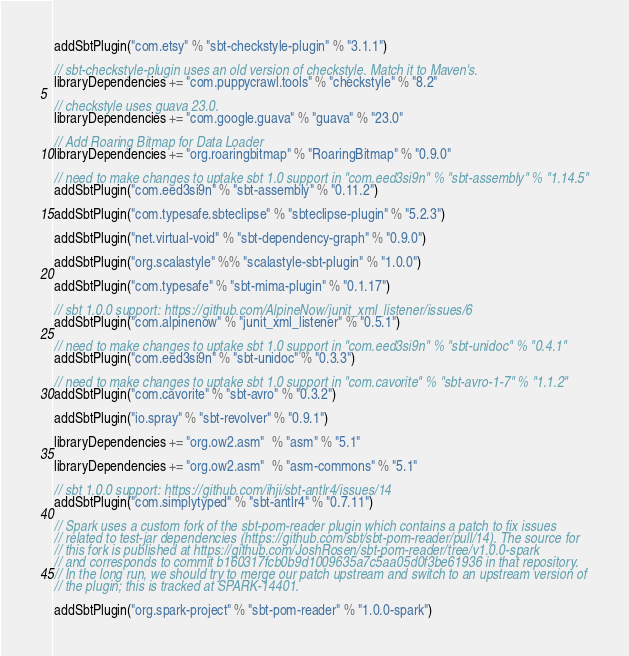<code> <loc_0><loc_0><loc_500><loc_500><_Scala_>addSbtPlugin("com.etsy" % "sbt-checkstyle-plugin" % "3.1.1")

// sbt-checkstyle-plugin uses an old version of checkstyle. Match it to Maven's.
libraryDependencies += "com.puppycrawl.tools" % "checkstyle" % "8.2"

// checkstyle uses guava 23.0.
libraryDependencies += "com.google.guava" % "guava" % "23.0"

// Add Roaring Bitmap for Data Loader
libraryDependencies += "org.roaringbitmap" % "RoaringBitmap" % "0.9.0"

// need to make changes to uptake sbt 1.0 support in "com.eed3si9n" % "sbt-assembly" % "1.14.5"
addSbtPlugin("com.eed3si9n" % "sbt-assembly" % "0.11.2")

addSbtPlugin("com.typesafe.sbteclipse" % "sbteclipse-plugin" % "5.2.3")

addSbtPlugin("net.virtual-void" % "sbt-dependency-graph" % "0.9.0")

addSbtPlugin("org.scalastyle" %% "scalastyle-sbt-plugin" % "1.0.0")

addSbtPlugin("com.typesafe" % "sbt-mima-plugin" % "0.1.17")

// sbt 1.0.0 support: https://github.com/AlpineNow/junit_xml_listener/issues/6
addSbtPlugin("com.alpinenow" % "junit_xml_listener" % "0.5.1")

// need to make changes to uptake sbt 1.0 support in "com.eed3si9n" % "sbt-unidoc" % "0.4.1"
addSbtPlugin("com.eed3si9n" % "sbt-unidoc" % "0.3.3")

// need to make changes to uptake sbt 1.0 support in "com.cavorite" % "sbt-avro-1-7" % "1.1.2"
addSbtPlugin("com.cavorite" % "sbt-avro" % "0.3.2")

addSbtPlugin("io.spray" % "sbt-revolver" % "0.9.1")

libraryDependencies += "org.ow2.asm"  % "asm" % "5.1"

libraryDependencies += "org.ow2.asm"  % "asm-commons" % "5.1"

// sbt 1.0.0 support: https://github.com/ihji/sbt-antlr4/issues/14
addSbtPlugin("com.simplytyped" % "sbt-antlr4" % "0.7.11")

// Spark uses a custom fork of the sbt-pom-reader plugin which contains a patch to fix issues
// related to test-jar dependencies (https://github.com/sbt/sbt-pom-reader/pull/14). The source for
// this fork is published at https://github.com/JoshRosen/sbt-pom-reader/tree/v1.0.0-spark
// and corresponds to commit b160317fcb0b9d1009635a7c5aa05d0f3be61936 in that repository.
// In the long run, we should try to merge our patch upstream and switch to an upstream version of
// the plugin; this is tracked at SPARK-14401.

addSbtPlugin("org.spark-project" % "sbt-pom-reader" % "1.0.0-spark")
</code> 